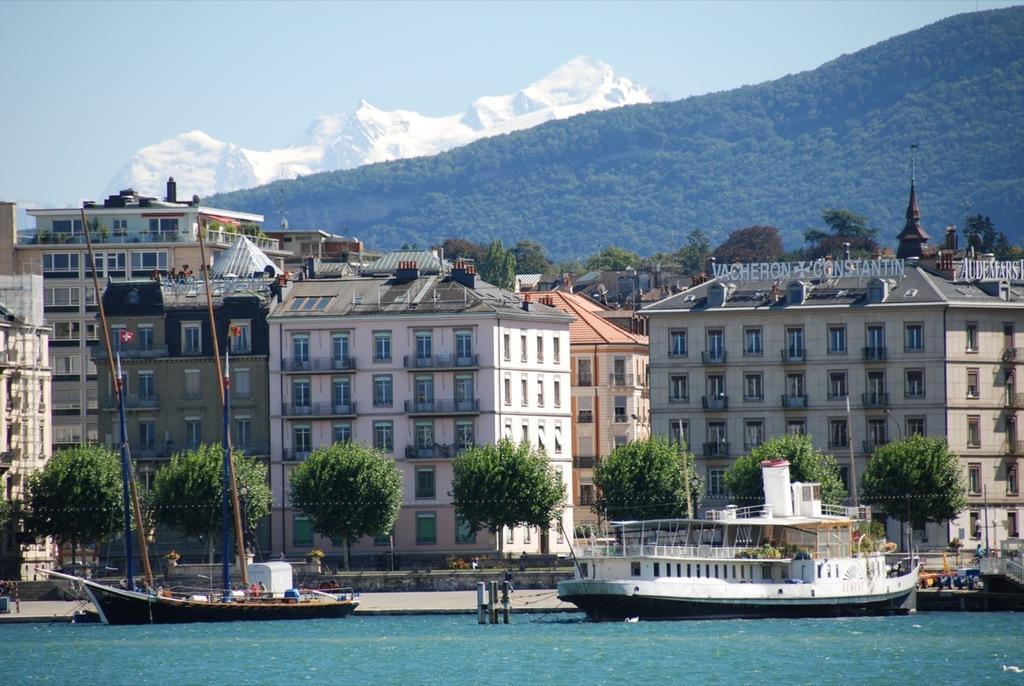In one or two sentences, can you explain what this image depicts? In the center of the image we can see the buildings, trees, fencing, wall, grass, stairs, road and some persons. At the bottom of the image we can see the boats are present on the water. In the background of the image we can see the hills, trees, snow mountains. At the top of the image we can see the sky. 